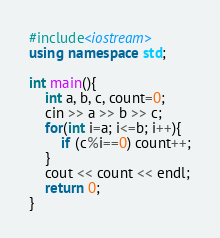<code> <loc_0><loc_0><loc_500><loc_500><_C++_>#include<iostream>
using namespace std;

int main(){
    int a, b, c, count=0;
    cin >> a >> b >> c;
    for(int i=a; i<=b; i++){
        if (c%i==0) count++;
    }
    cout << count << endl;
    return 0;
}
</code> 